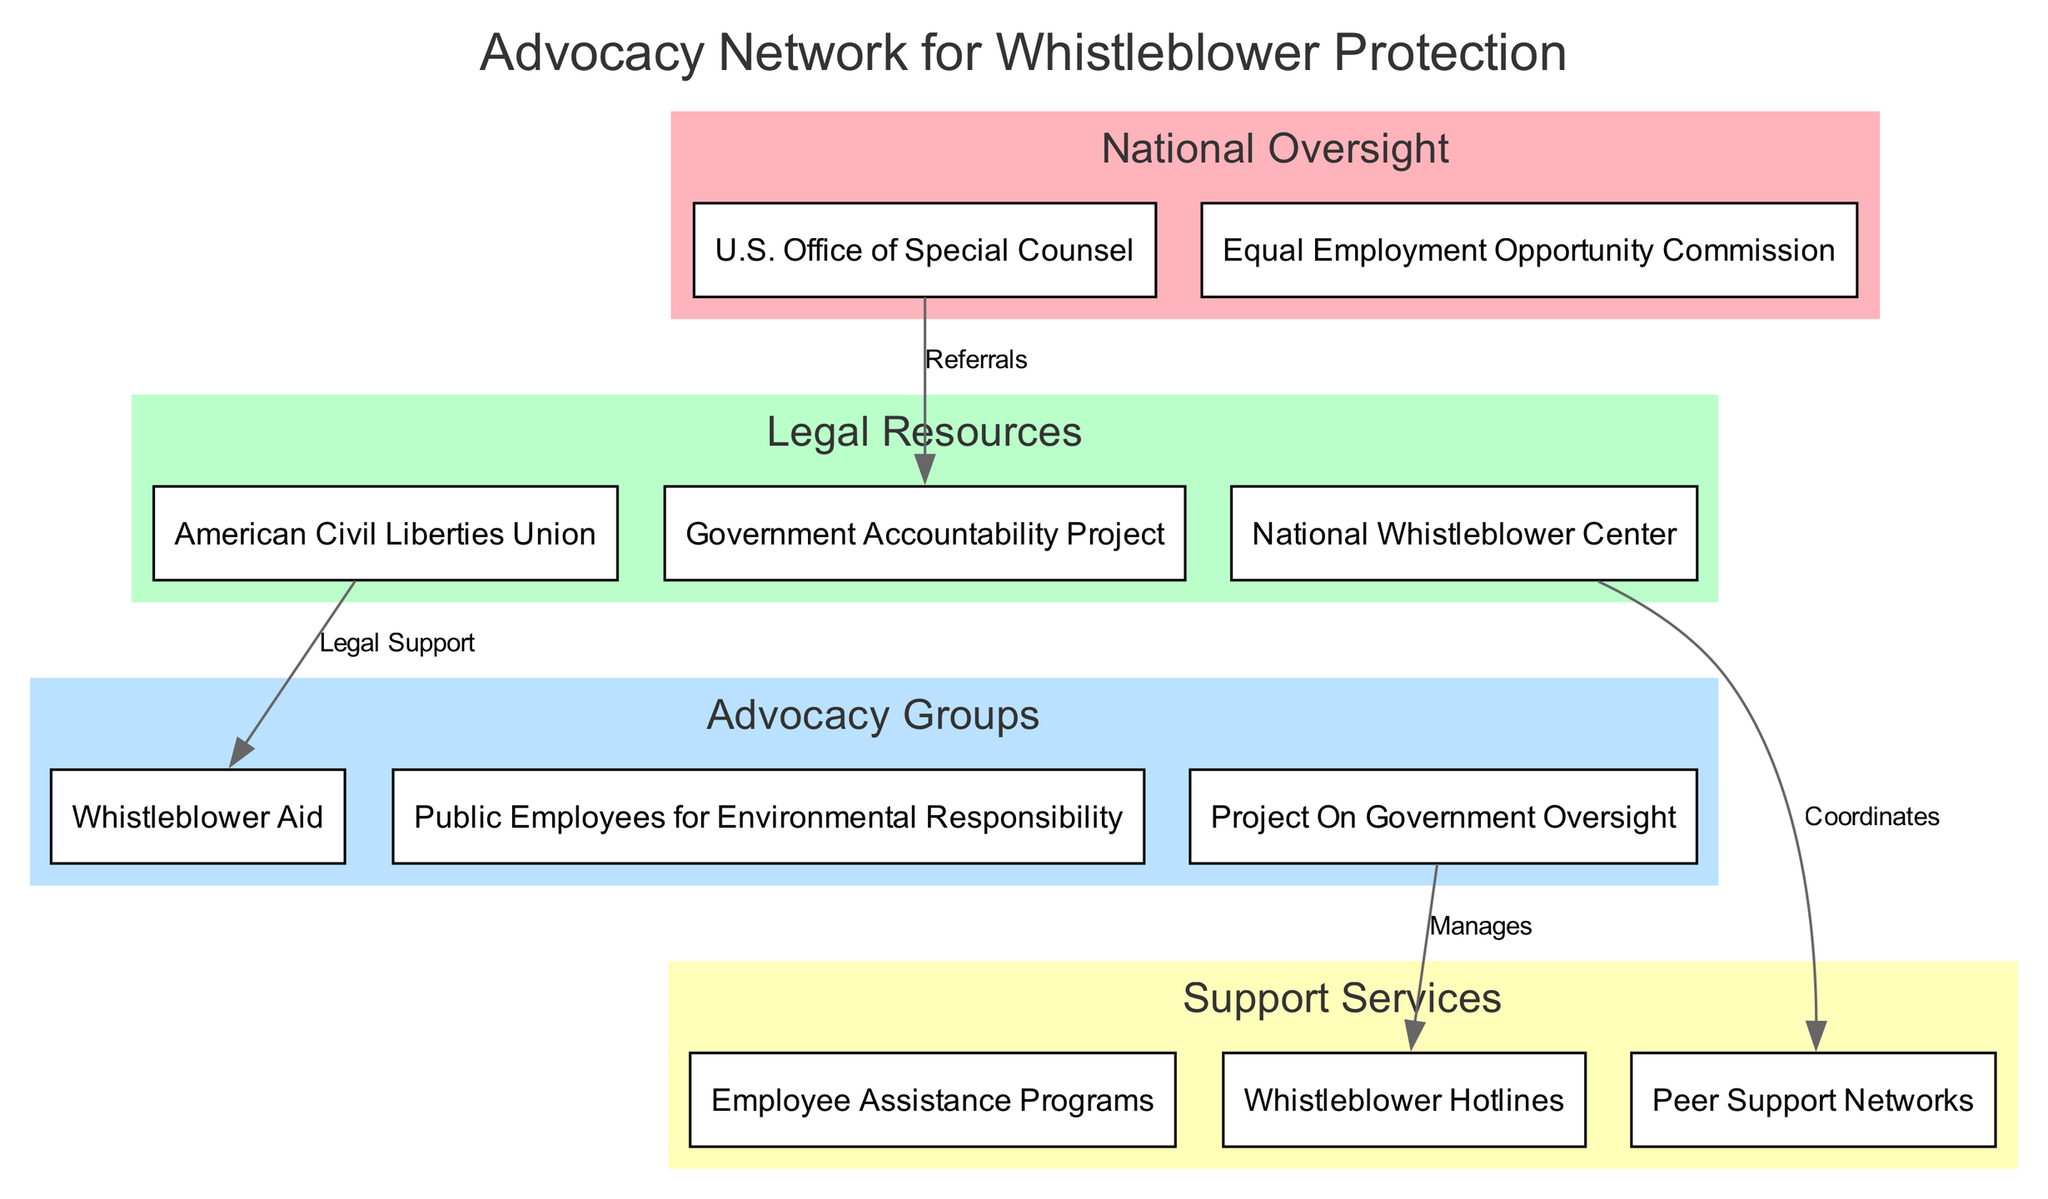What entities are located in the "Legal Resources" level? To find the entities in the "Legal Resources" level, we review the corresponding section in the diagram. This level includes three entities: the American Civil Liberties Union, Government Accountability Project, and National Whistleblower Center.
Answer: American Civil Liberties Union, Government Accountability Project, National Whistleblower Center How many entities are listed under the "Support Services" level? By counting the entities provided in the "Support Services" section, we find there are three: Employee Assistance Programs, Whistleblower Hotlines, and Peer Support Networks.
Answer: 3 Which entity manages the Whistleblower Hotlines? To answer this question, we look at the connections in the diagram. The line connecting Project On Government Oversight to Whistleblower Hotlines indicates that Project On Government Oversight manages these hotlines.
Answer: Project On Government Oversight What type of connection exists between the U.S. Office of Special Counsel and the Government Accountability Project? To find the type of connection, we check the label of the edge connecting these two entities. The label states "Referrals," which indicates the nature of the relationship.
Answer: Referrals Which two entities are connected by the label "Legal Support"? We examine the connections in the diagram, specifically looking for the label "Legal Support." This label appears between the American Civil Liberties Union and Whistleblower Aid, indicating they are connected by this relationship.
Answer: American Civil Liberties Union, Whistleblower Aid What is the top level in the hierarchy depicted in this diagram? The levels are organized such that the topmost level is clearly marked. In this case, the "National Oversight" level is the highest, featuring entities like the U.S. Office of Special Counsel and Equal Employment Opportunity Commission.
Answer: National Oversight How many connections are shown between the entities across the different levels? By counting all the connections listed under the "connections" section in the diagram, we find there are four defined connections indicating relationships between entities.
Answer: 4 Which entity coordinates with Peer Support Networks? To identify this, we examine the connections for a relationship involving Peer Support Networks. The label "Coordinates" connects the National Whistleblower Center to this entity, indicating its role in coordination.
Answer: National Whistleblower Center What is the purpose of the connections marked "Manages" in the diagram? Upon inspecting the diagram, the connection labeled "Manages" involves Project On Government Oversight and Whistleblower Hotlines. Thus, this connection implies that Project On Government Oversight oversees the operations of the Whistleblower Hotlines.
Answer: Project On Government Oversight 